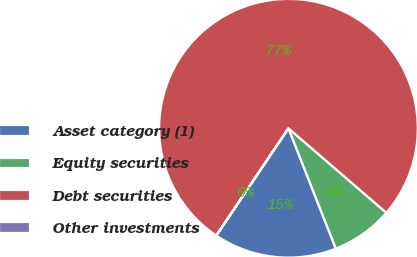Convert chart. <chart><loc_0><loc_0><loc_500><loc_500><pie_chart><fcel>Asset category (1)<fcel>Equity securities<fcel>Debt securities<fcel>Other investments<nl><fcel>15.39%<fcel>7.7%<fcel>76.91%<fcel>0.01%<nl></chart> 